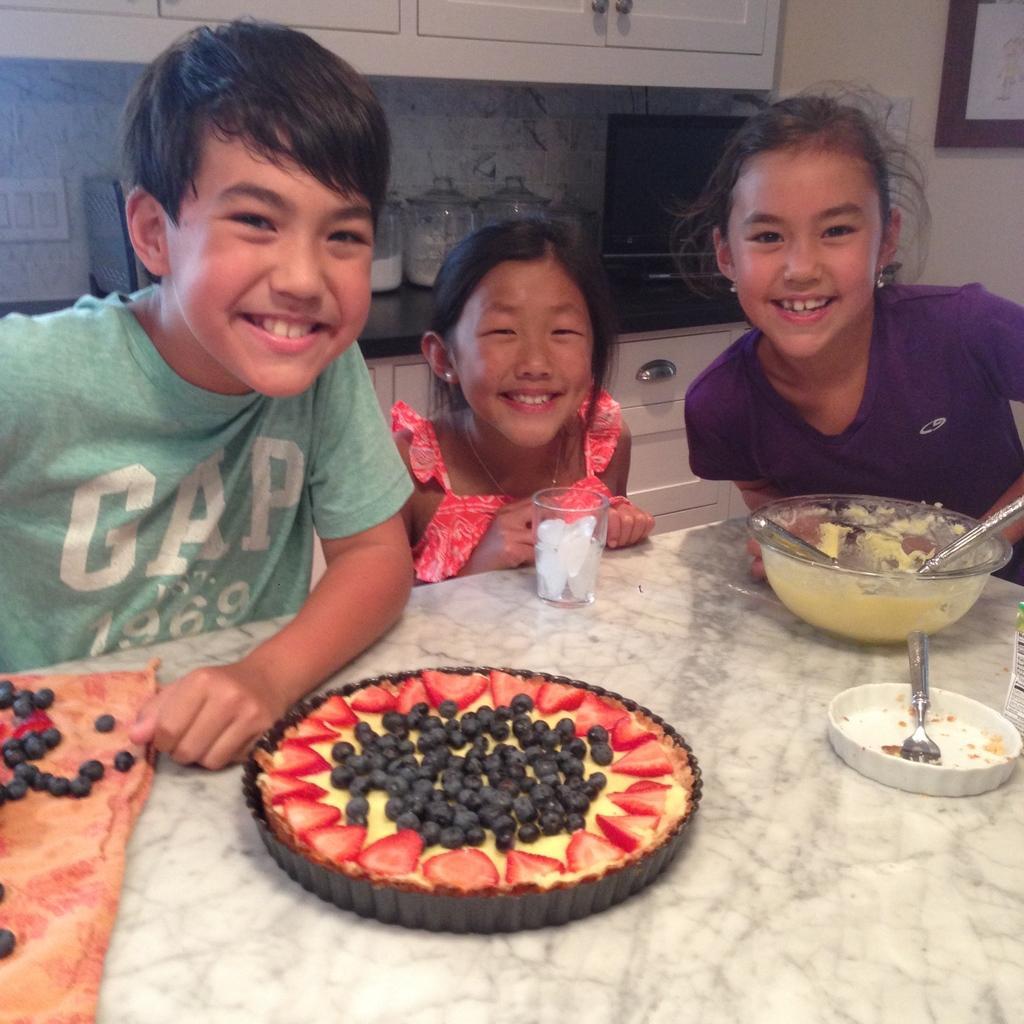Could you give a brief overview of what you see in this image? In this image on the right, there is a girl, she wears a t shirt. In the middle there is a girl, she wears a dress. On the left there is a boy, he wears a t shirt, in front of them there is a table on that there are fruits, tart, bowl, glass, grapes, strawberries and some other food items. In the background there are cupboards, vessels, photo frame and wall. 